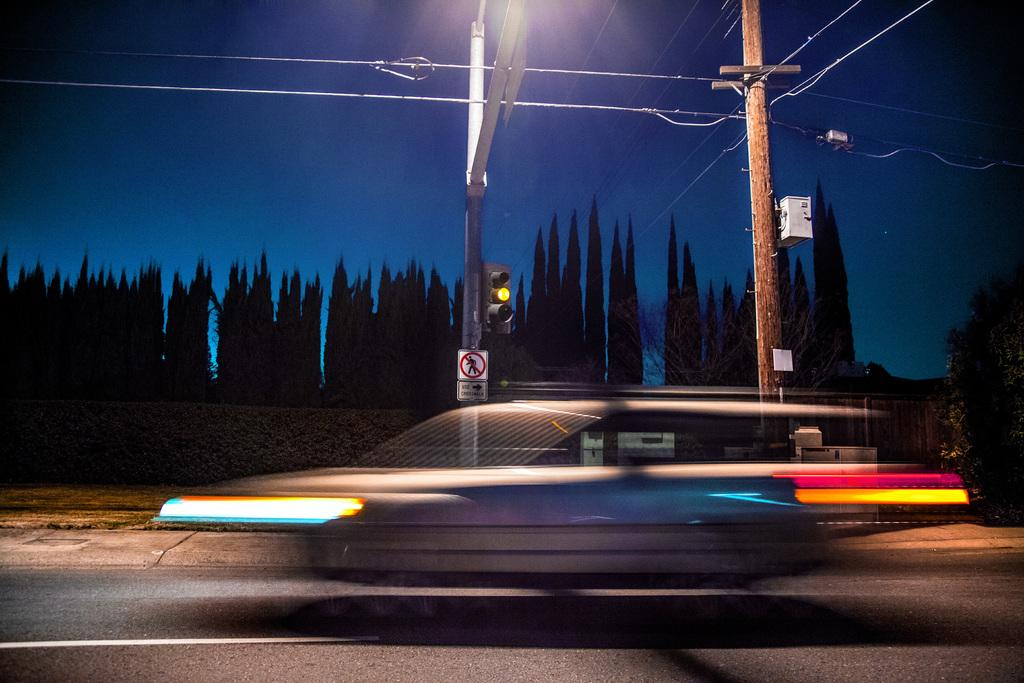What is on the road in the image? There is a vehicle on the road in the image. How would you describe the appearance of the vehicle? The vehicle appears to be blurry. What can be seen in the background of the image? There is a traffic signal, a sign board, electric poles, and trees visible in the background of the image. What type of jar is sitting on the vehicle in the image? There is no jar present on the vehicle in the image. What is the name of the thing that is blurry in the image? The blurry object in the image is a vehicle, and it does not have a name. 